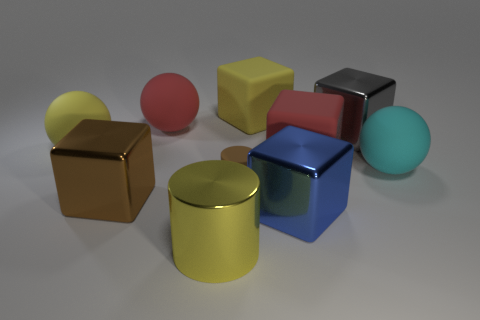Does the yellow cube have the same material as the red thing on the left side of the big blue metallic block?
Offer a very short reply. Yes. The small matte cylinder has what color?
Your response must be concise. Brown. What number of red matte things are in front of the big yellow rubber object to the left of the shiny block that is on the left side of the big blue shiny cube?
Provide a succinct answer. 1. Are there any small cylinders behind the large yellow rubber block?
Make the answer very short. No. What number of big red things are the same material as the large blue object?
Your answer should be very brief. 0. What number of objects are either large matte spheres or small things?
Make the answer very short. 4. Are there any brown matte cylinders?
Keep it short and to the point. Yes. What material is the cyan sphere on the right side of the metallic block that is behind the sphere right of the tiny brown thing?
Offer a very short reply. Rubber. Is the number of blue metal blocks behind the gray shiny thing less than the number of small brown objects?
Offer a very short reply. Yes. What is the material of the gray thing that is the same size as the cyan sphere?
Your response must be concise. Metal. 